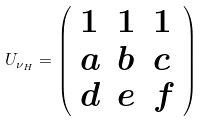Convert formula to latex. <formula><loc_0><loc_0><loc_500><loc_500>U _ { \nu _ { H } } = \left ( \begin{array} { l l l } { 1 } & { 1 } & { 1 } \\ { a } & { b } & { c } \\ { d } & { e } & { f } \end{array} \right )</formula> 